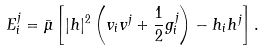<formula> <loc_0><loc_0><loc_500><loc_500>E ^ { j } _ { i } = \bar { \mu } \left [ | h | ^ { 2 } \left ( v _ { i } v ^ { j } + \frac { 1 } { 2 } g ^ { j } _ { i } \right ) - h _ { i } h ^ { j } \right ] .</formula> 